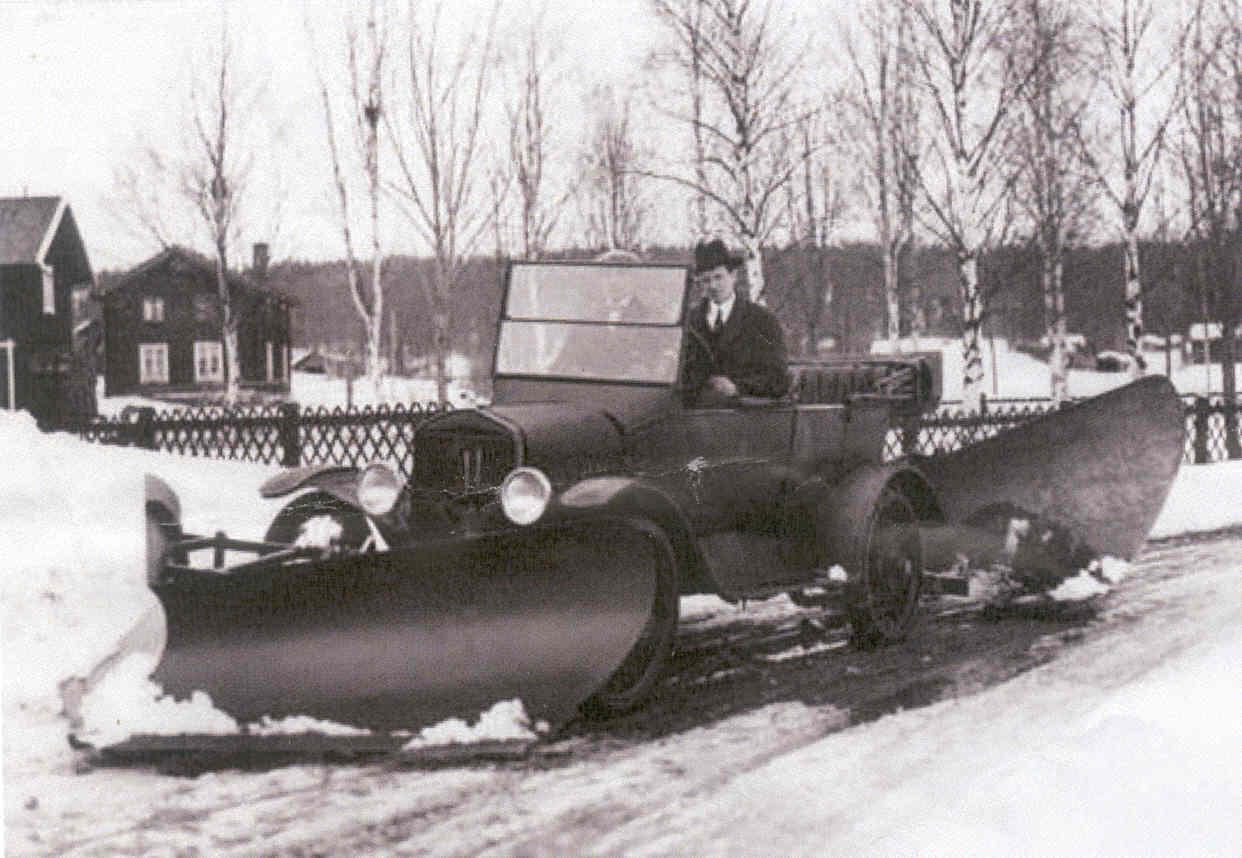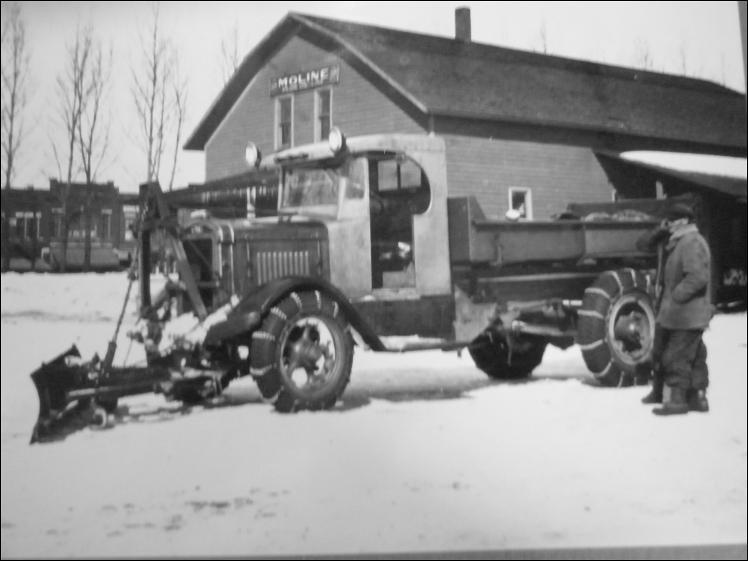The first image is the image on the left, the second image is the image on the right. Analyze the images presented: Is the assertion "Both images in the pair are in black and white." valid? Answer yes or no. Yes. The first image is the image on the left, the second image is the image on the right. Considering the images on both sides, is "In at least one image there is a single motorized snow plow going left." valid? Answer yes or no. Yes. 